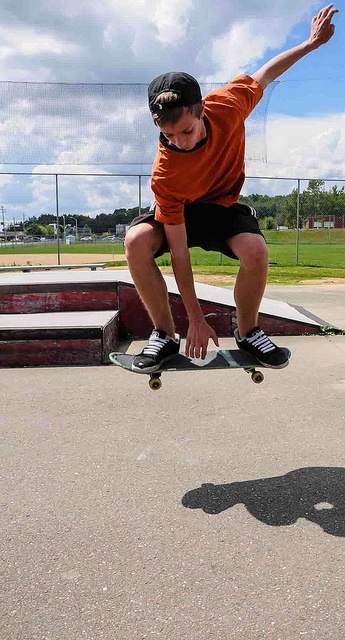Describe the objects in this image and their specific colors. I can see people in darkgray, maroon, black, and brown tones and skateboard in darkgray, black, gray, and darkgreen tones in this image. 